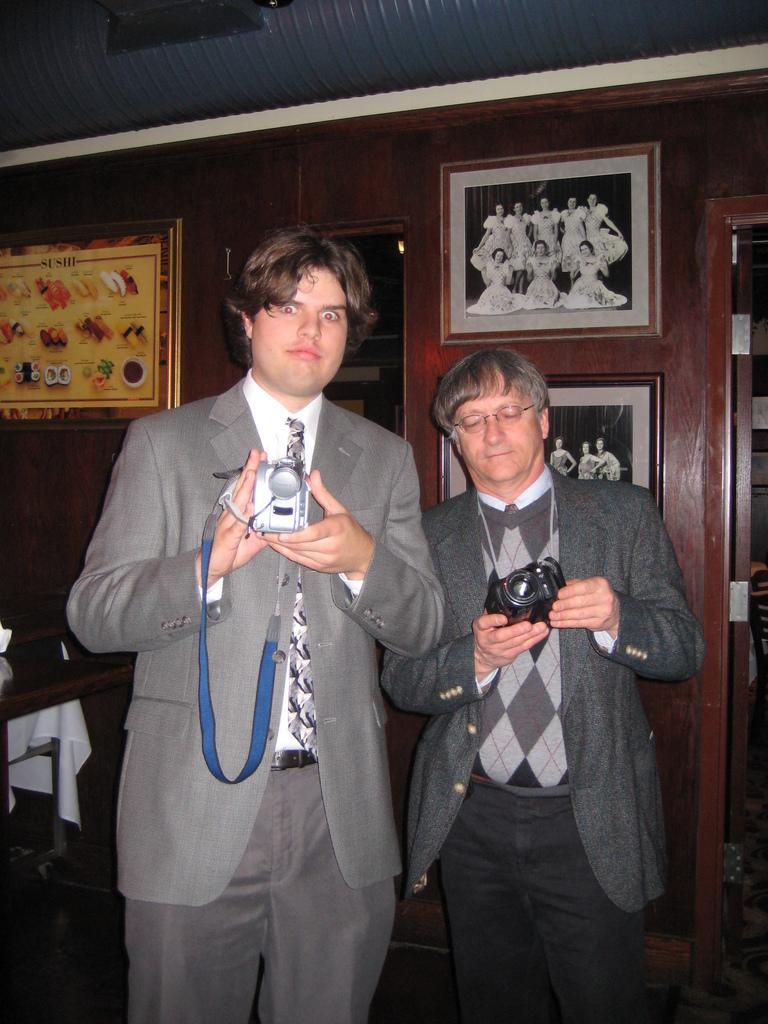In one or two sentences, can you explain what this image depicts? In this image we can see few people standing and holding the cameras. There are few photos on the wall. We can see a table and few objects on it. There is a door at the right side of the image. 